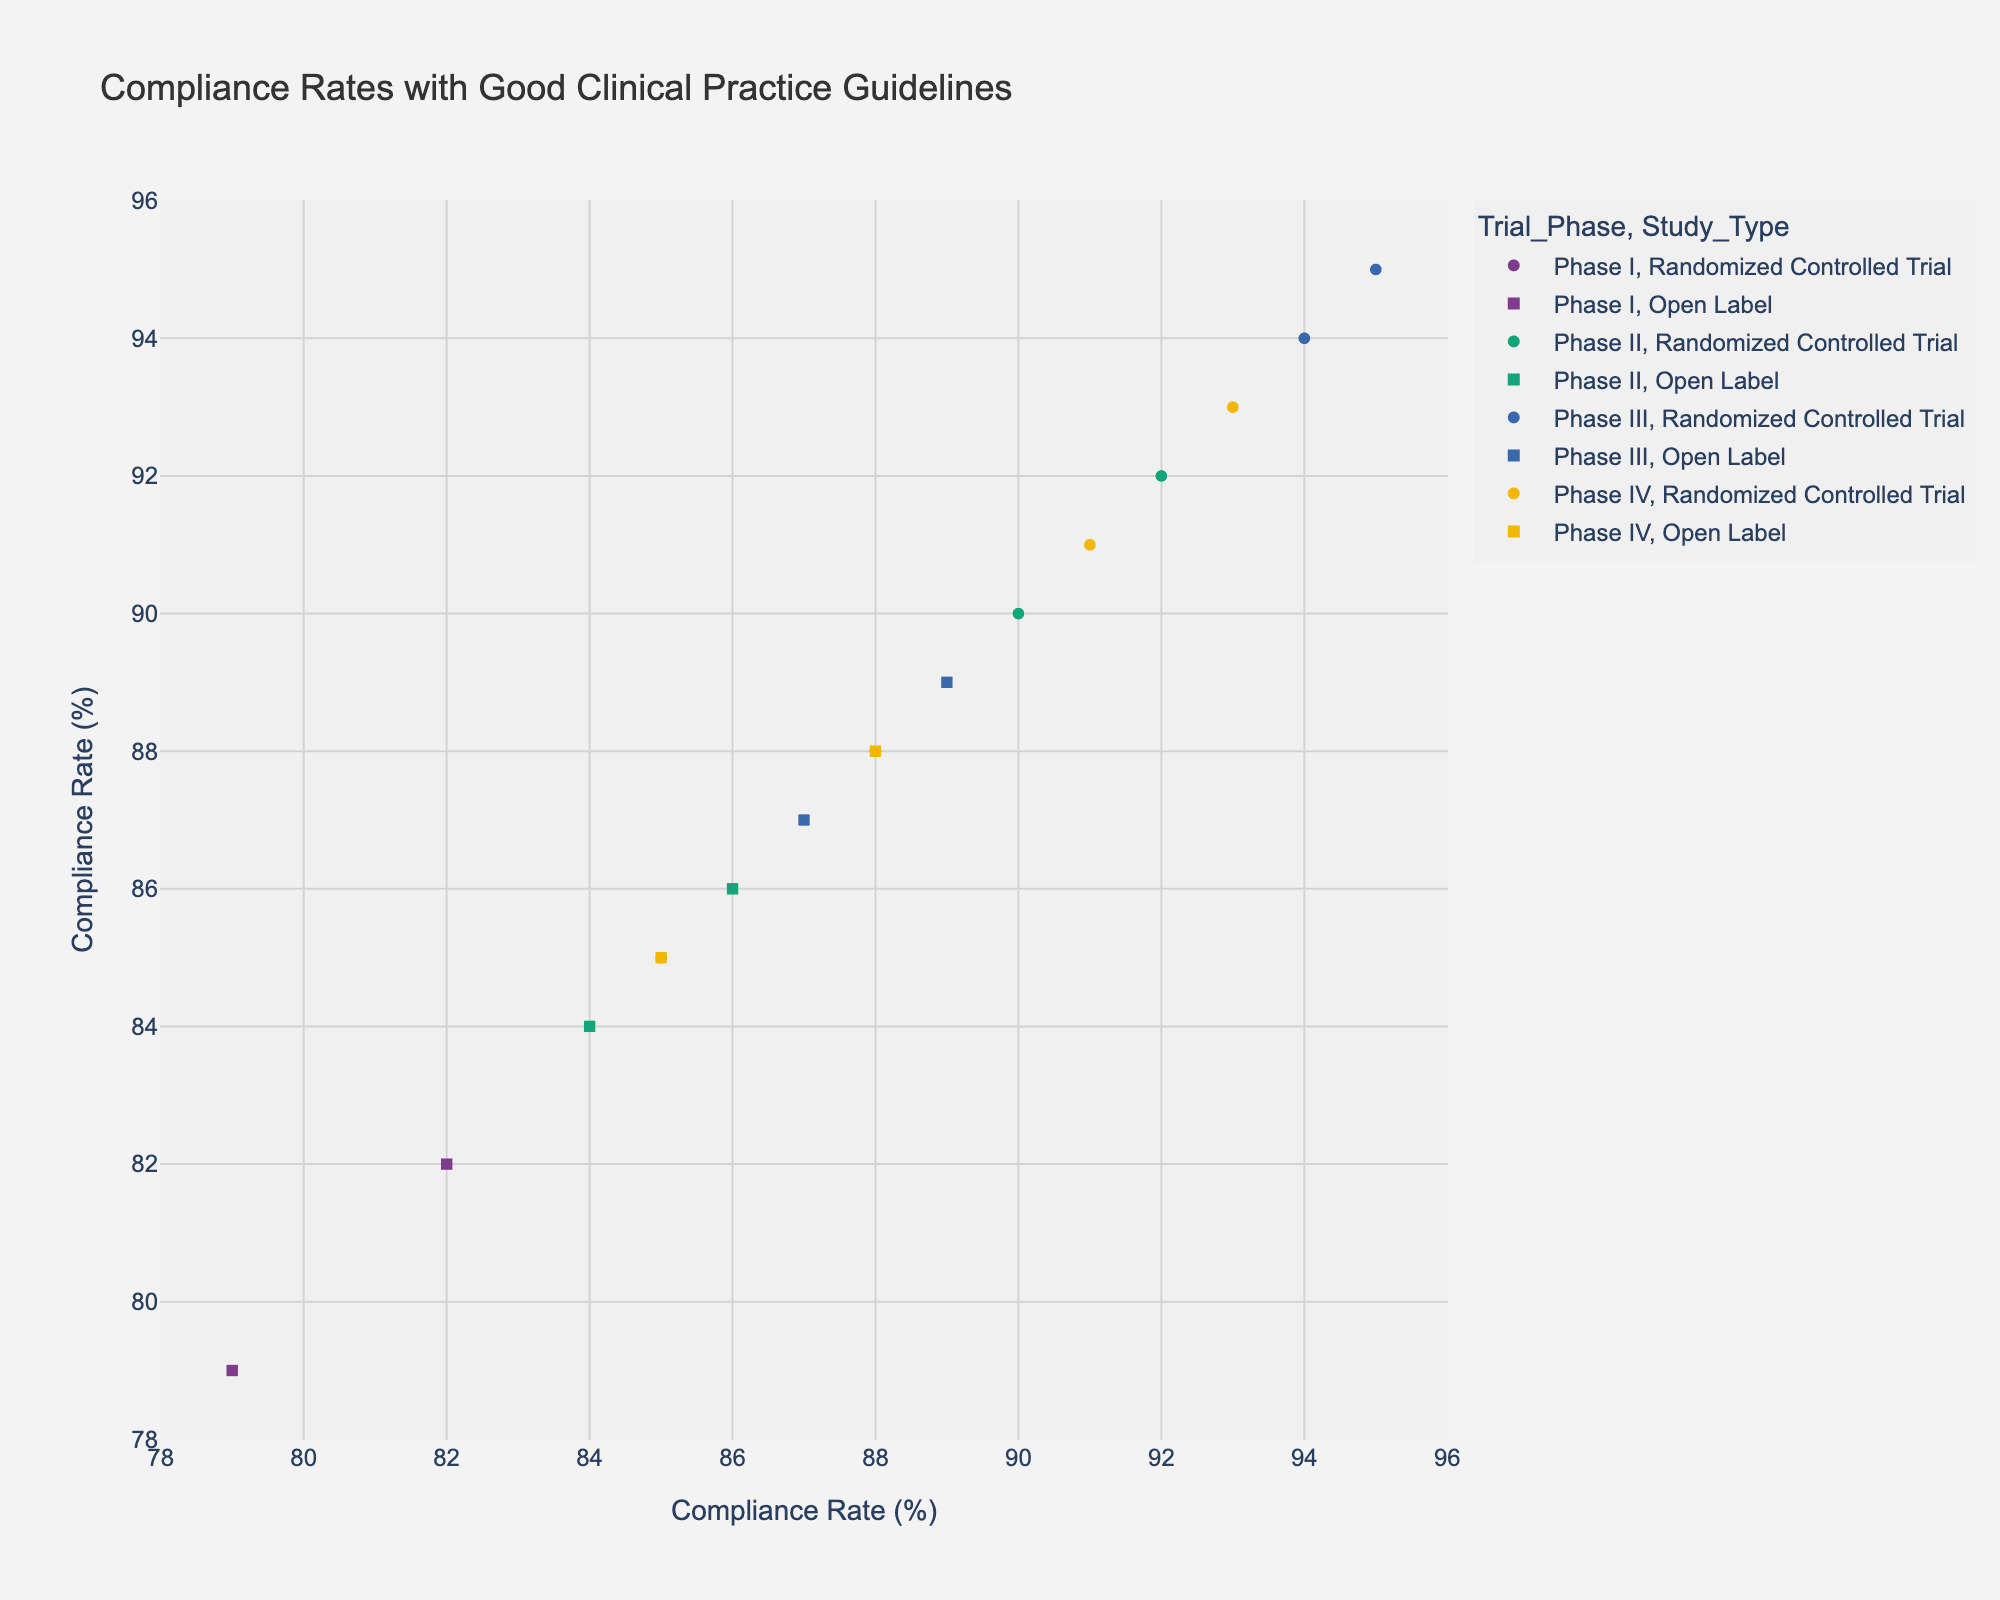what is the title of the figure? The title is typically located at the top of the figure. It provides a summary of the data being visualized.
Answer: Compliance Rates with Good Clinical Practice Guidelines How many phases of clinical trials are represented in the figure? To determine the number of clinical trial phases, look at the color legend which shows the different phases.
Answer: 4 Which geographical location has the highest compliance rate in Phase I? Identify the points corresponding to Phase I in the scatter plot, then hover over or look at the legend to identify the geographical location with the highest compliance rate.
Answer: Europe What is the average compliance rate for Open Label studies in Phase II? Identify the points corresponding to Open Label studies in Phase II, sum their compliance rates, and divide by the number of these studies.
(86+84)/2 = 85
Answer: 85 Are compliance rates generally higher in Phase III or Phase IV across all geographical locations? Compare the compliance rates of data points for Phase III with those for Phase IV to see which phase has higher rates overall.
Answer: Phase III Which study type exhibits more variation in compliance rates in Phase I, Randomized Controlled Trials or Open Label studies? Compare the spread of the compliance rate points for Randomized Controlled Trials and Open Label studies in Phase I.
Answer: Open Label studies Which geographic location has the lowest compliance rate for any phase? Identify the data point with the lowest compliance rate and check its geographical location.
Answer: South America Is there a progressive increase in compliance rates from Phase I to Phase IV? Compare the compliance rates across different phases starting from Phase I to Phase IV.
No, there isn't a steady increase; individual points vary.
Answer: No Do Randomized Controlled Trials consistently show higher compliance rates than Open Label studies in all phases? Compare the compliance rates of Randomized Controlled Trials with those of Open Label studies for each phase.
Answer: Yes In which phase is the difference between the highest and lowest compliance rates largest? Calculate the difference between the highest and lowest compliance rates in each phase and identify the phase with the largest difference.
Answer: Phase I 